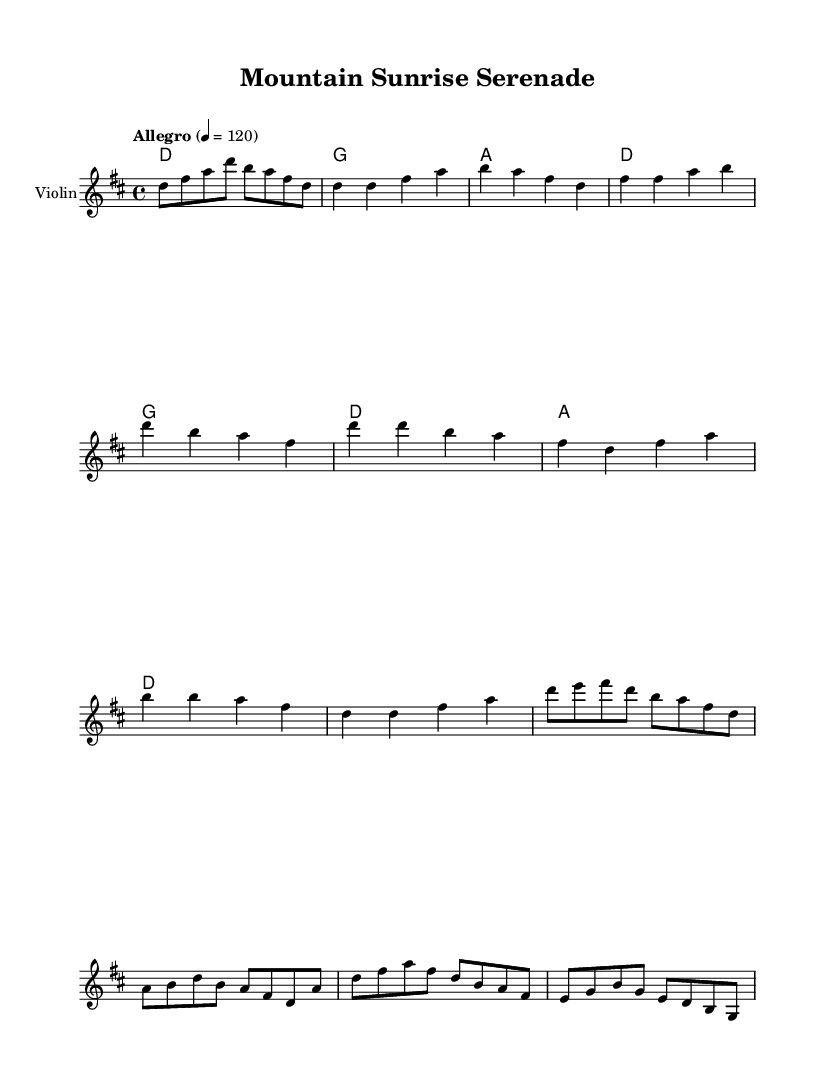What is the key signature of this music? The key signature is identified by looking at the beginning of the staff where sharps or flats are noted. In this sheet music, there is a single sharp, indicating that the key is D major.
Answer: D major What is the time signature of this music? The time signature is found at the beginning of the score indicated by the numbers. Here, the 4/4 time signature shows there are four beats in each measure and the quarter note receives one beat.
Answer: 4/4 What is the tempo marking? The tempo marking is indicated by the word "Allegro" followed by a metronome marking of 120, suggesting a fast pace for the music.
Answer: Allegro How many measures does the Fiddle Break section contain? Looking closely at the Fiddle Break segment in the notation, there are two measures that make up this section.
Answer: 2 What is the first note of the Fiddle Solo? The Fiddle Solo starts with the note 'd', which can be confirmed from the sheet music at the beginning of this section.
Answer: d What type of chord is predominantly used in the Verse section? Analyzing the harmonies for the Verse section, the chords visible are primarily D, G, and A major chords which are typical in country rock. The first chord is a D major chord.
Answer: D major Is there a repeat in the Chorus section? Checking for any repeat signs in the Chorus shows that there are no repeat signs present, indicating that the Chorus plays through only once.
Answer: No 